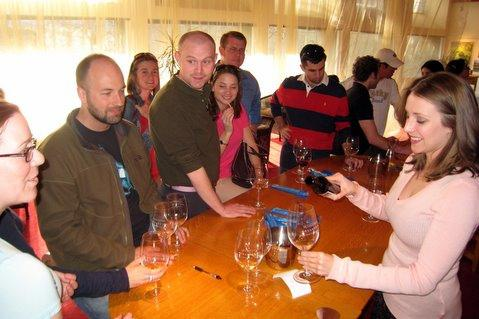What kind of event is this? wine tasting 